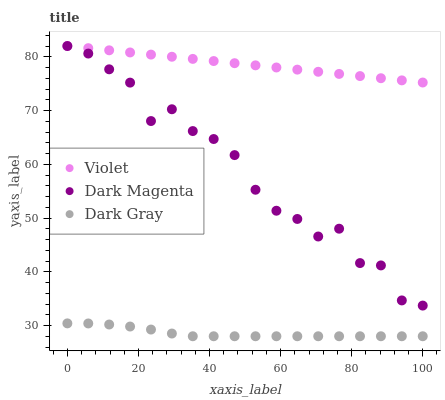Does Dark Gray have the minimum area under the curve?
Answer yes or no. Yes. Does Violet have the maximum area under the curve?
Answer yes or no. Yes. Does Dark Magenta have the minimum area under the curve?
Answer yes or no. No. Does Dark Magenta have the maximum area under the curve?
Answer yes or no. No. Is Violet the smoothest?
Answer yes or no. Yes. Is Dark Magenta the roughest?
Answer yes or no. Yes. Is Dark Magenta the smoothest?
Answer yes or no. No. Is Violet the roughest?
Answer yes or no. No. Does Dark Gray have the lowest value?
Answer yes or no. Yes. Does Dark Magenta have the lowest value?
Answer yes or no. No. Does Violet have the highest value?
Answer yes or no. Yes. Is Dark Gray less than Dark Magenta?
Answer yes or no. Yes. Is Violet greater than Dark Gray?
Answer yes or no. Yes. Does Dark Magenta intersect Violet?
Answer yes or no. Yes. Is Dark Magenta less than Violet?
Answer yes or no. No. Is Dark Magenta greater than Violet?
Answer yes or no. No. Does Dark Gray intersect Dark Magenta?
Answer yes or no. No. 